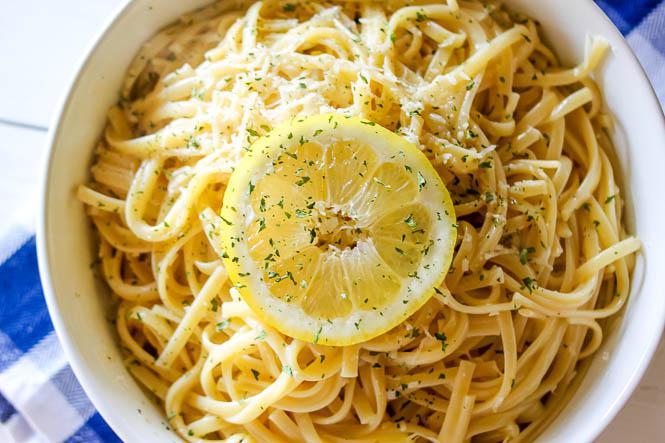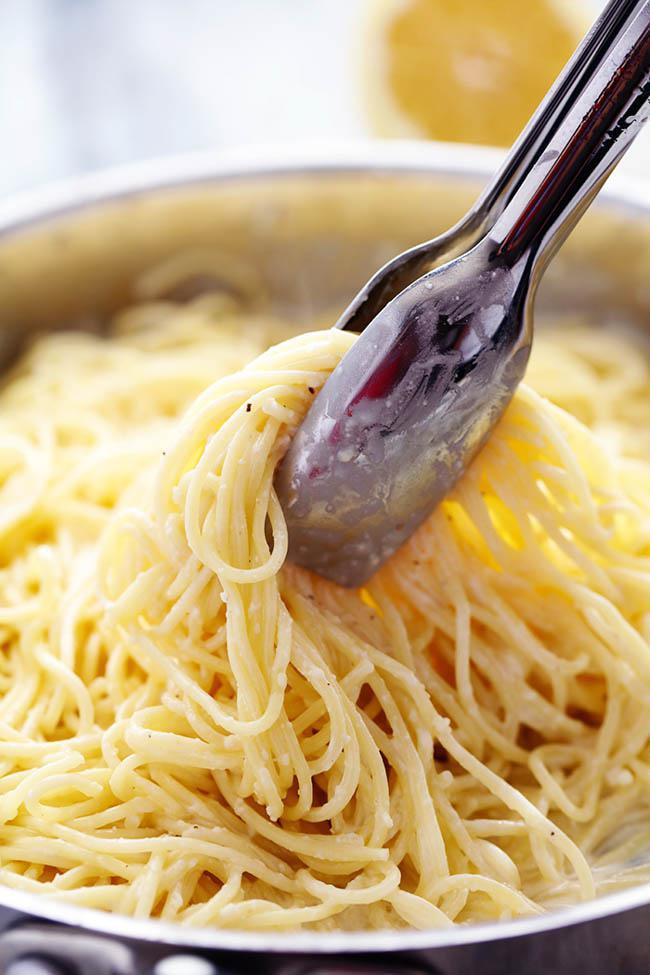The first image is the image on the left, the second image is the image on the right. Evaluate the accuracy of this statement regarding the images: "An image shows a slice of citrus fruit garnishing a white bowl of noodles on a checkered cloth.". Is it true? Answer yes or no. Yes. 